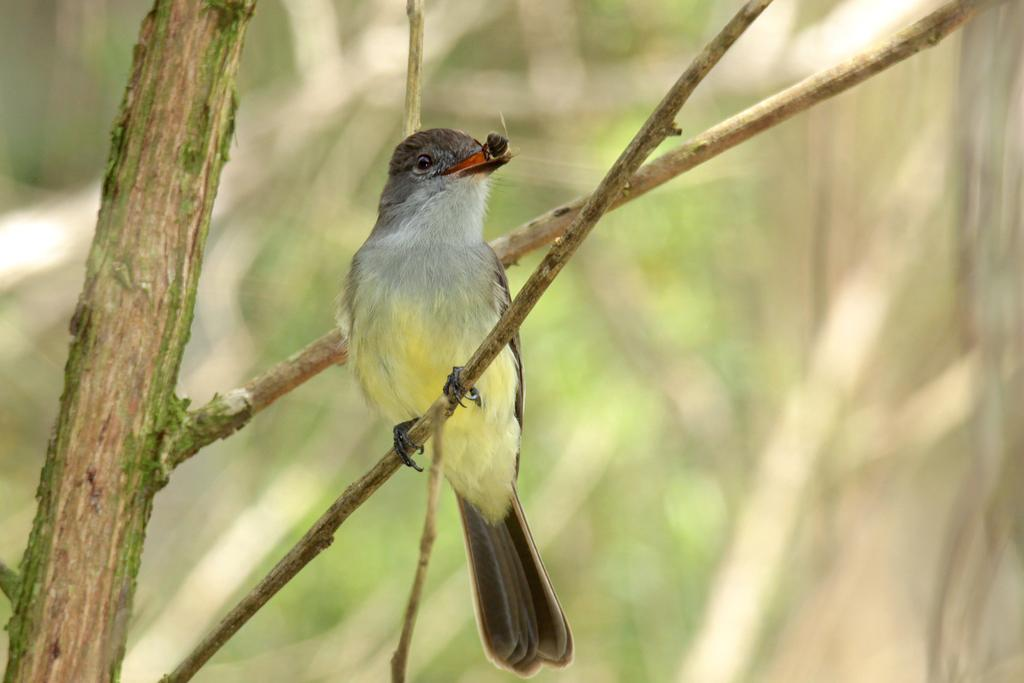What type of animal can be seen in the image? There is a bird in the image. Where is the bird located? The bird is on a branch of a tree. Can you describe the background of the image? The background of the image is blurred. Is the bird wearing a crown in the image? No, the bird is not wearing a crown in the image. What type of rod is the bird holding in the image? There is no rod present in the image; the bird is simply perched on a branch. 